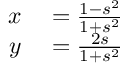<formula> <loc_0><loc_0><loc_500><loc_500>\begin{array} { r l } { x } & = { \frac { 1 - s ^ { 2 } } { 1 + s ^ { 2 } } } } \\ { y } & = { \frac { 2 s } { 1 + s ^ { 2 } } } } \end{array}</formula> 